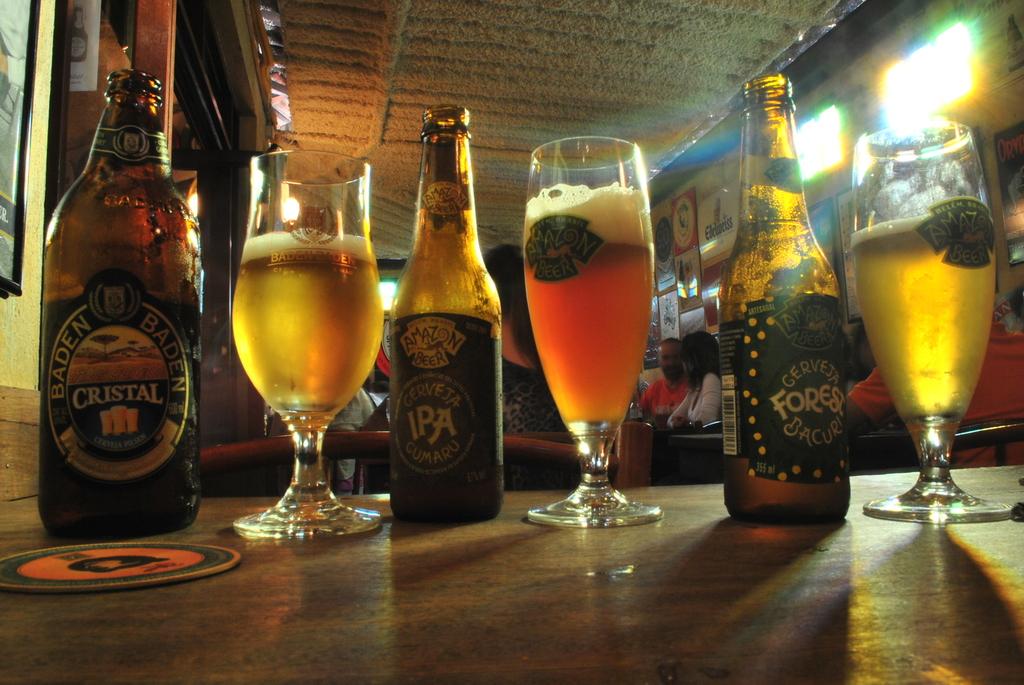What is the brand of the beer ?
Ensure brevity in your answer.  Amazon beer. 